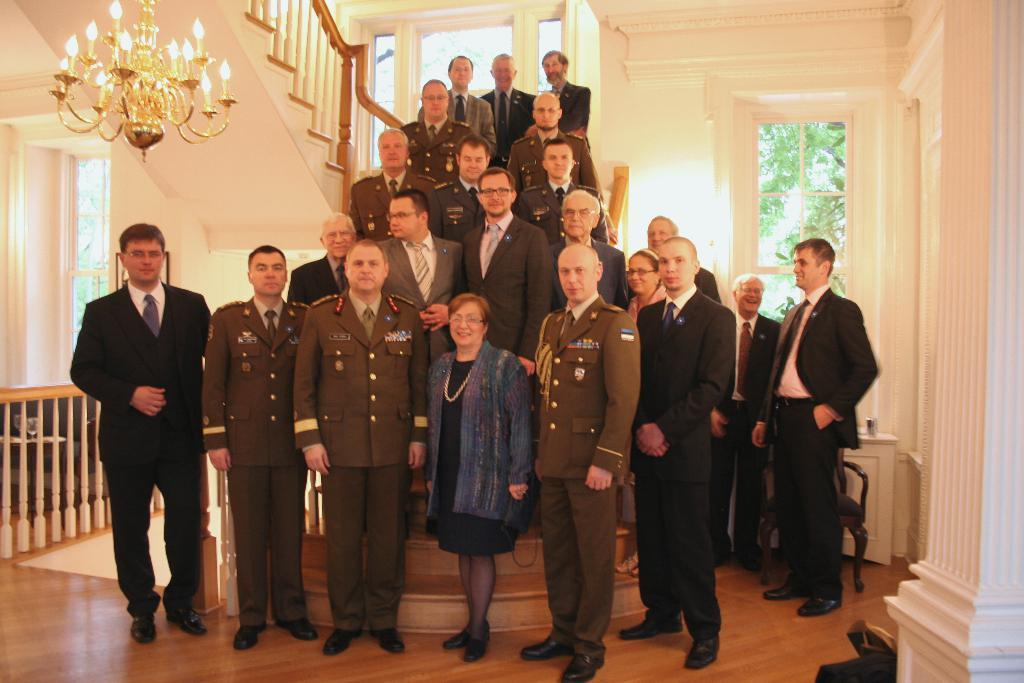How many people are in the image? There is a group of people in the image. Where are the people standing in the image? The people are standing on the floor and steps. What is hanging from the ceiling in the image? There is a chandelier in the image. What type of furniture is present in the image? There are chairs in the image. What can be seen through the windows in the image? Trees are visible through the windows. What architectural feature is present in the image? There is a fence in the image. What type of meat is being served during the recess in the image? There is no recess or meat present in the image. 